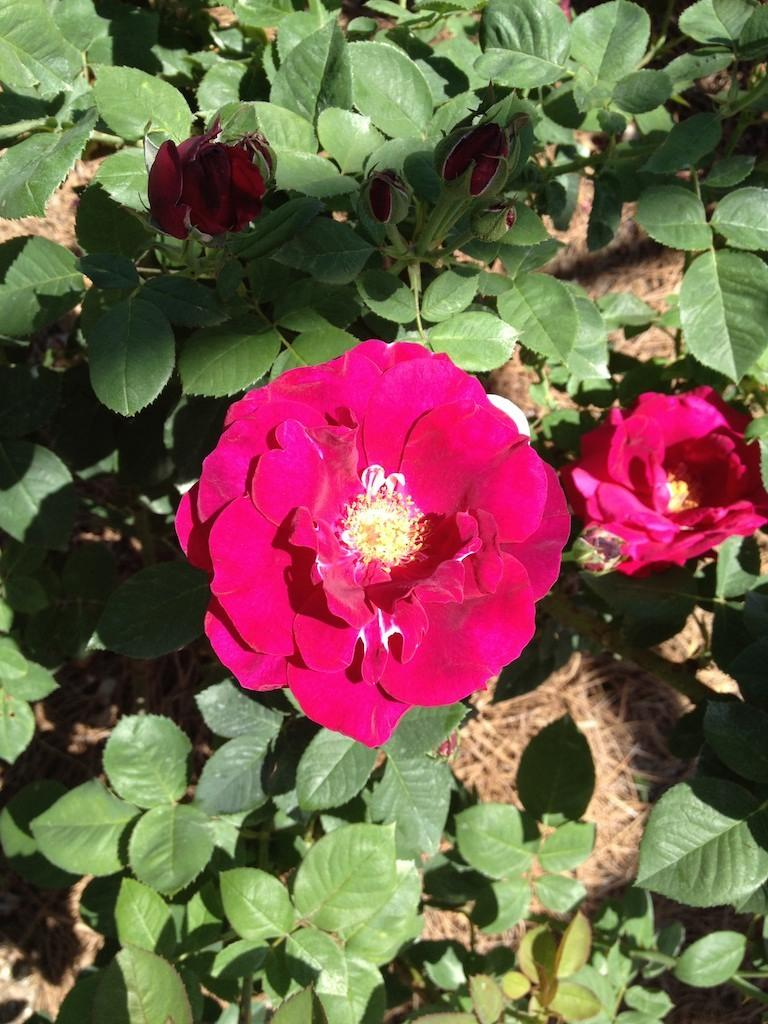What type of plants can be seen in the image? There are flowers, buds, and green plants in the image. Can you describe the stage of growth for the plants in the image? The presence of both flowers and buds suggests that the plants are at different stages of growth. What type of potato is being prepared by the fireman in the image? There is no potato or fireman present in the image; it features flowers, buds, and green plants. 